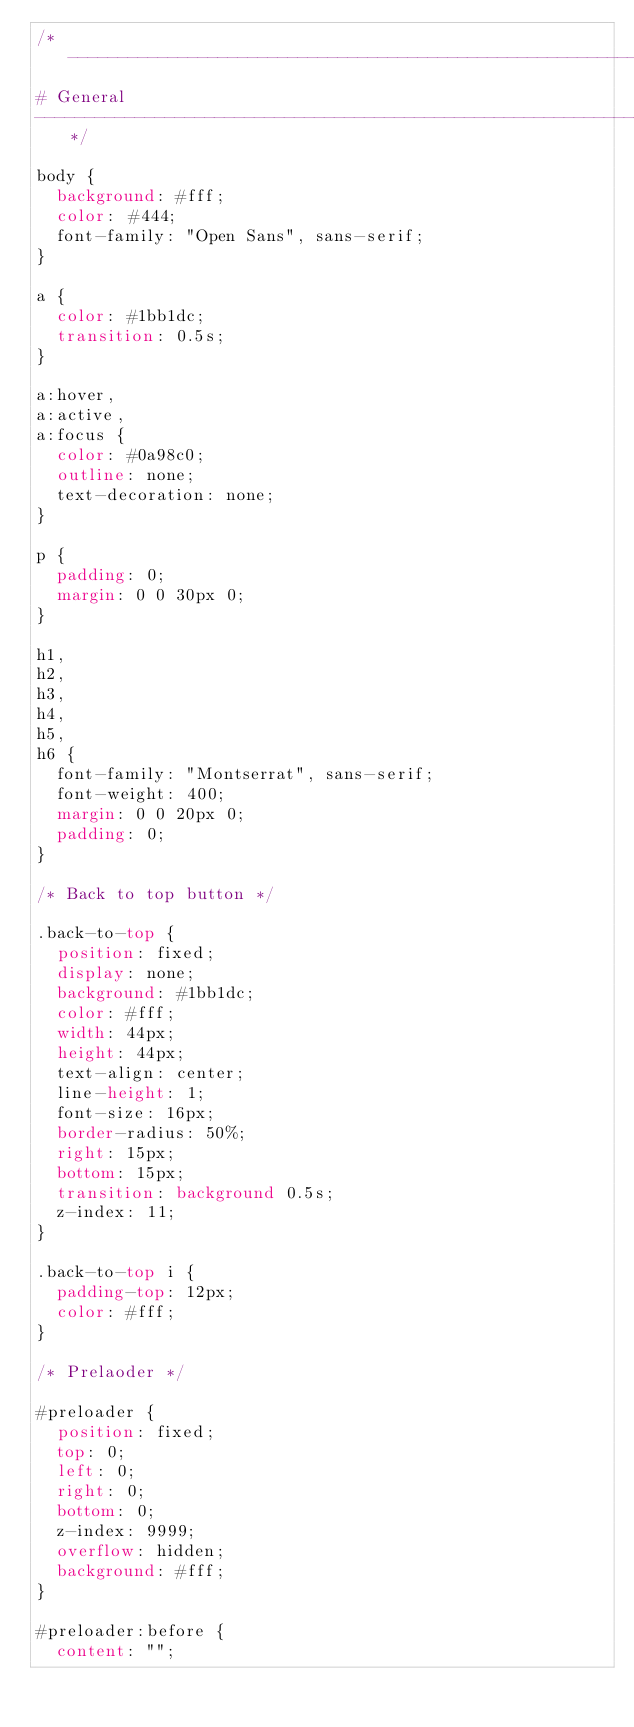Convert code to text. <code><loc_0><loc_0><loc_500><loc_500><_CSS_>/*--------------------------------------------------------------
# General
--------------------------------------------------------------*/

body {
  background: #fff;
  color: #444;
  font-family: "Open Sans", sans-serif;
}

a {
  color: #1bb1dc;
  transition: 0.5s;
}

a:hover,
a:active,
a:focus {
  color: #0a98c0;
  outline: none;
  text-decoration: none;
}

p {
  padding: 0;
  margin: 0 0 30px 0;
}

h1,
h2,
h3,
h4,
h5,
h6 {
  font-family: "Montserrat", sans-serif;
  font-weight: 400;
  margin: 0 0 20px 0;
  padding: 0;
}

/* Back to top button */

.back-to-top {
  position: fixed;
  display: none;
  background: #1bb1dc;
  color: #fff;
  width: 44px;
  height: 44px;
  text-align: center;
  line-height: 1;
  font-size: 16px;
  border-radius: 50%;
  right: 15px;
  bottom: 15px;
  transition: background 0.5s;
  z-index: 11;
}

.back-to-top i {
  padding-top: 12px;
  color: #fff;
}

/* Prelaoder */

#preloader {
  position: fixed;
  top: 0;
  left: 0;
  right: 0;
  bottom: 0;
  z-index: 9999;
  overflow: hidden;
  background: #fff;
}

#preloader:before {
  content: "";</code> 